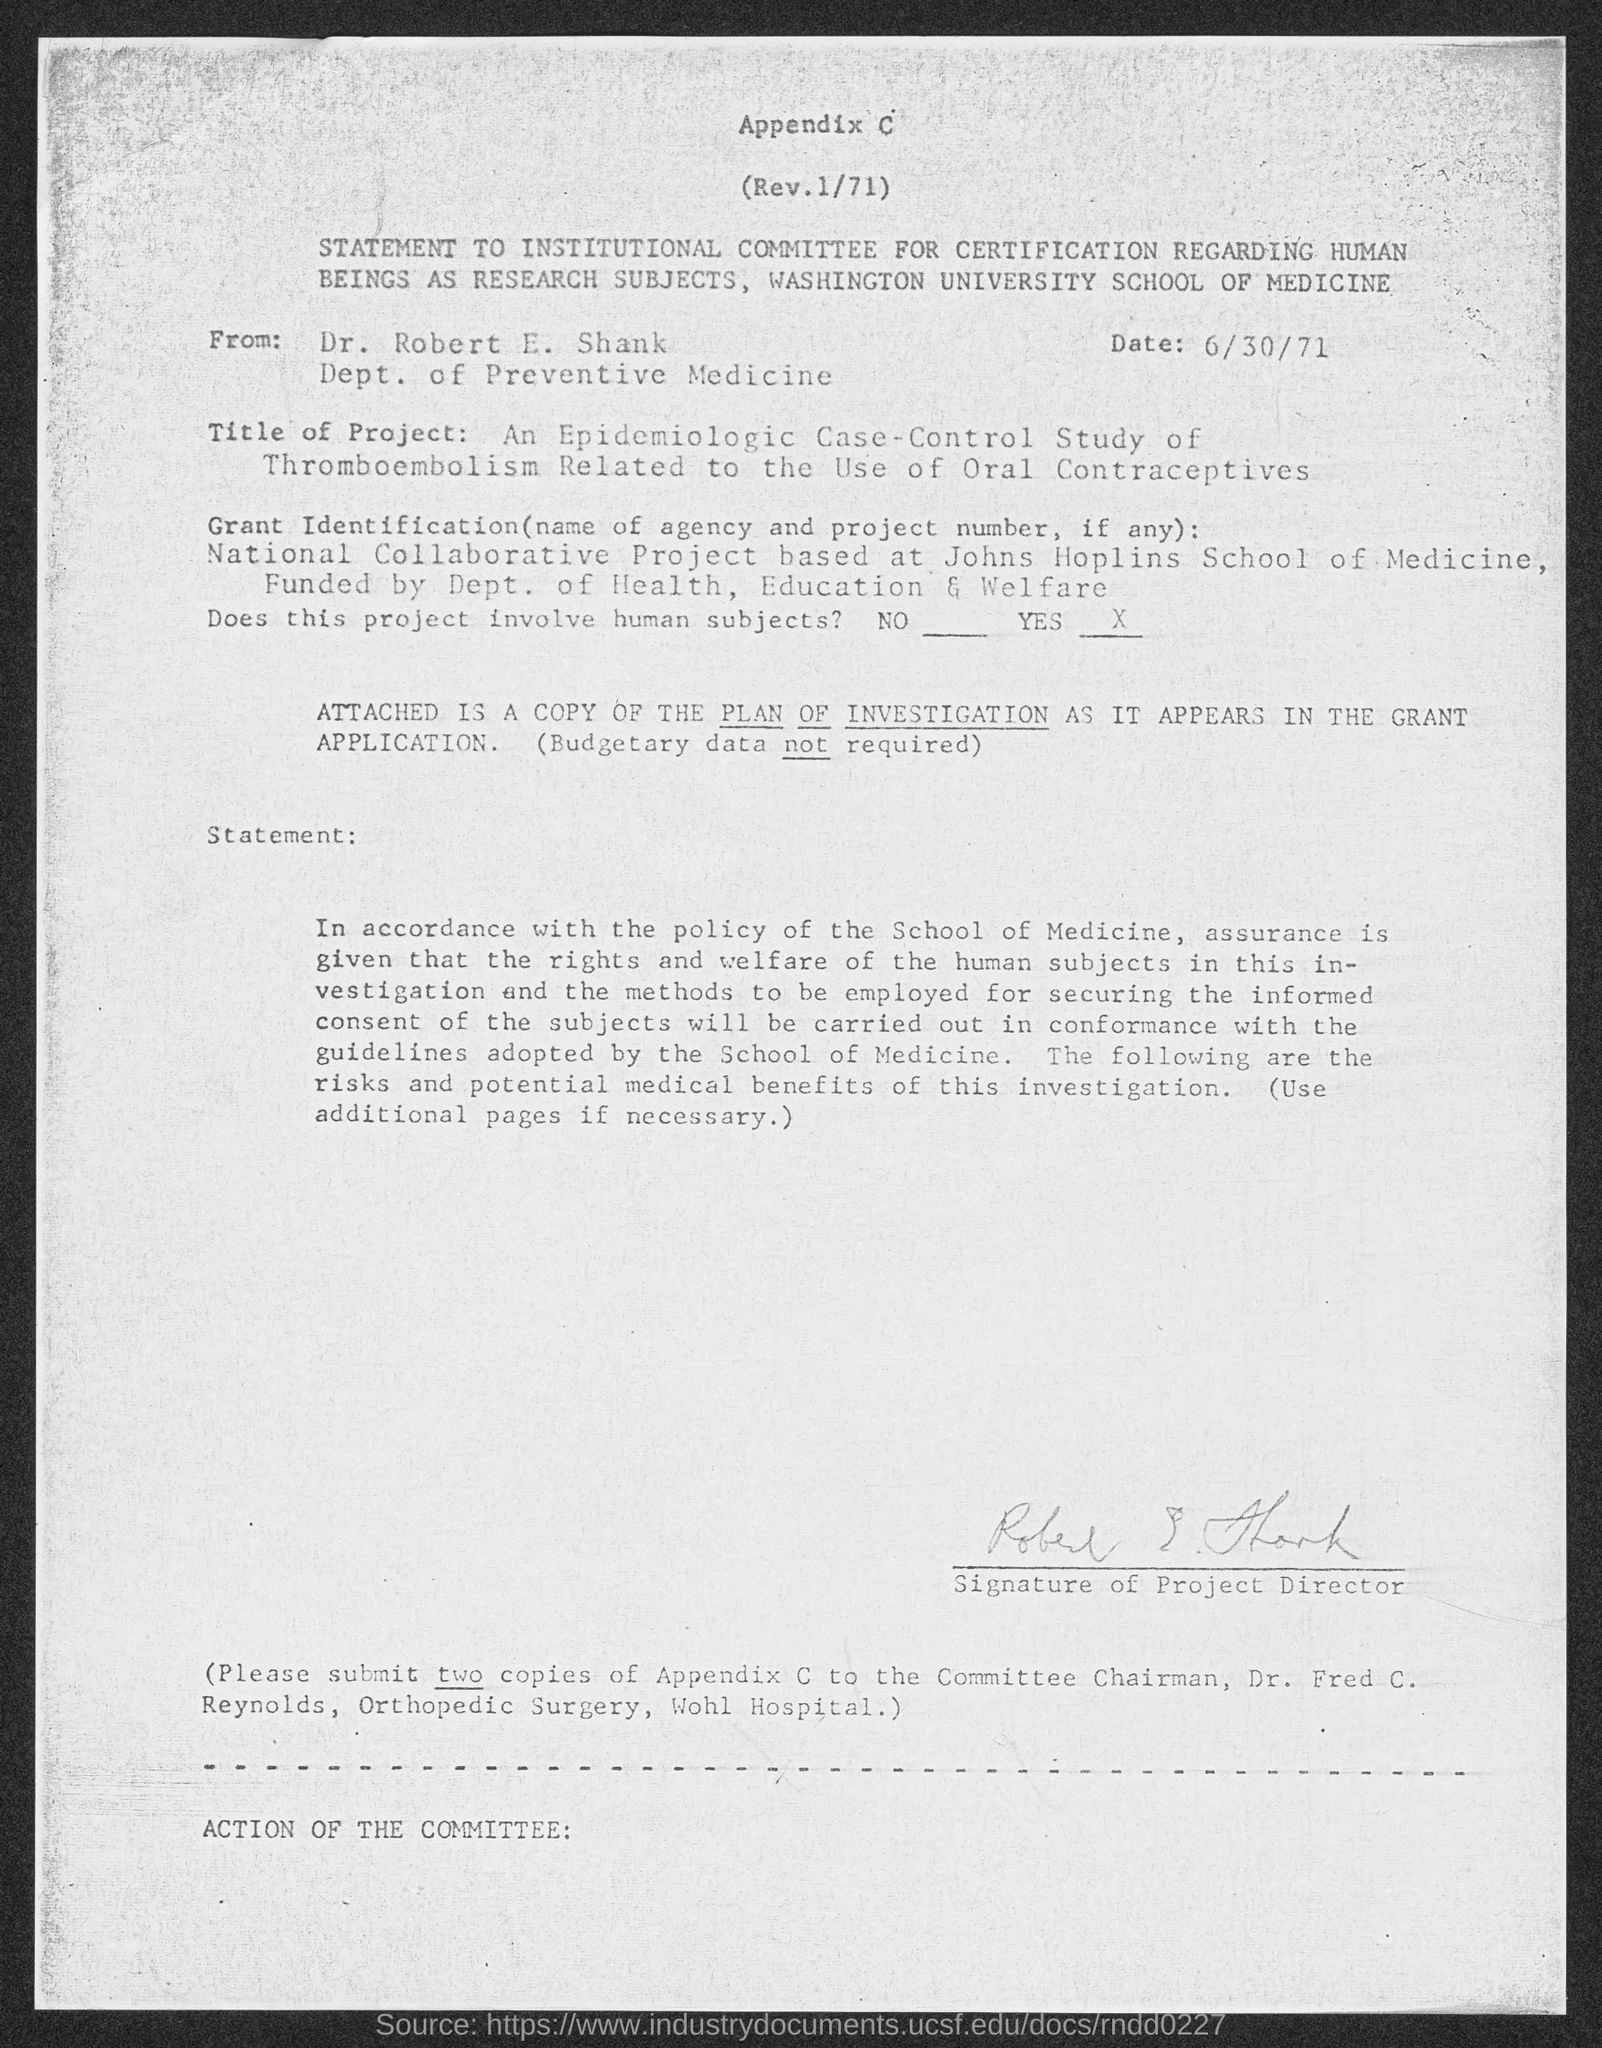What is the Date?
Offer a very short reply. 6/30/71. Who is this letter from?
Offer a very short reply. DR. ROBERT E. SHANK. 